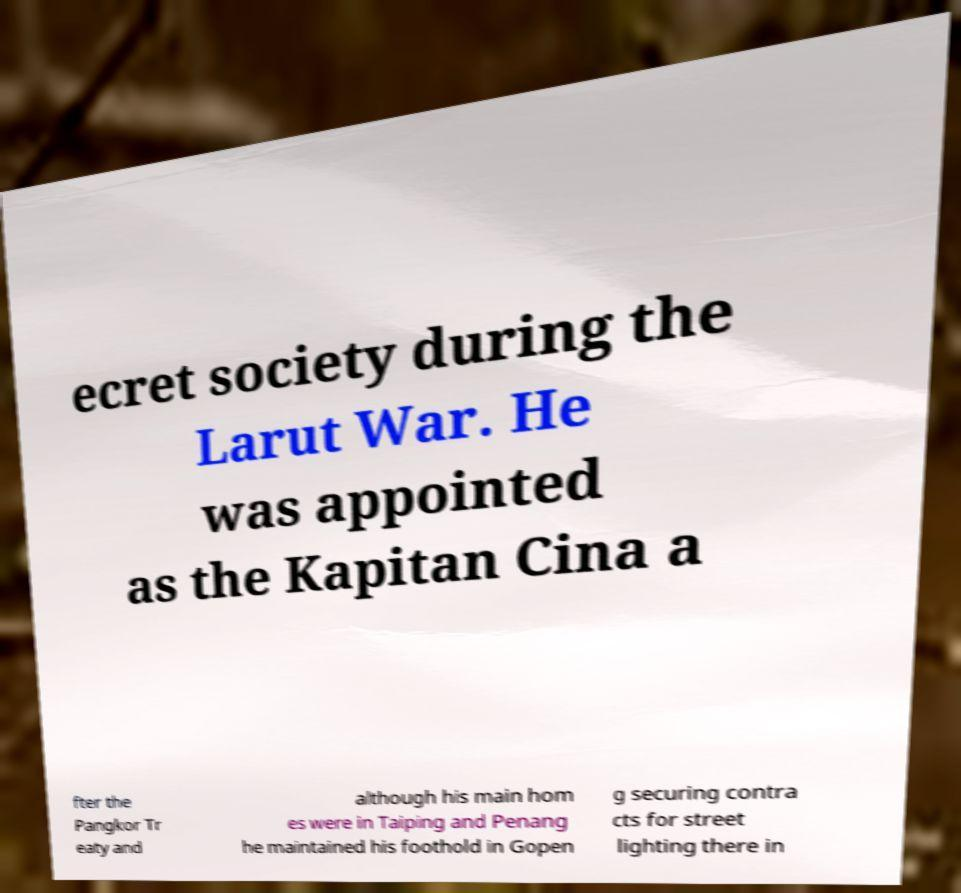Please identify and transcribe the text found in this image. ecret society during the Larut War. He was appointed as the Kapitan Cina a fter the Pangkor Tr eaty and although his main hom es were in Taiping and Penang he maintained his foothold in Gopen g securing contra cts for street lighting there in 